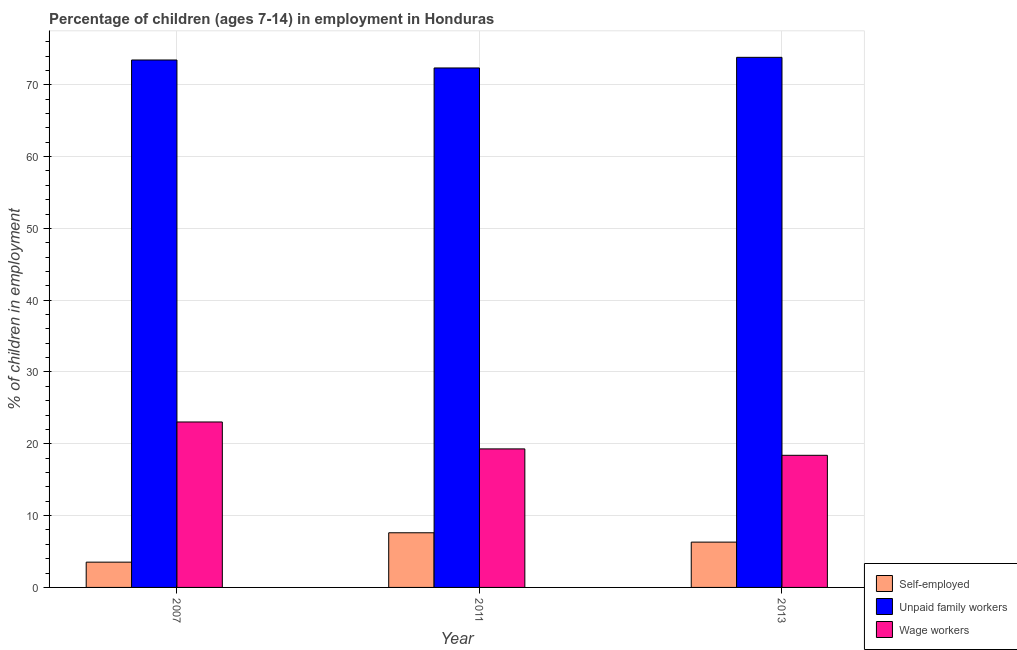How many different coloured bars are there?
Your response must be concise. 3. How many groups of bars are there?
Provide a short and direct response. 3. Are the number of bars on each tick of the X-axis equal?
Give a very brief answer. Yes. How many bars are there on the 2nd tick from the left?
Your response must be concise. 3. How many bars are there on the 1st tick from the right?
Your response must be concise. 3. What is the percentage of children employed as unpaid family workers in 2011?
Ensure brevity in your answer.  72.34. Across all years, what is the maximum percentage of children employed as unpaid family workers?
Your response must be concise. 73.82. Across all years, what is the minimum percentage of children employed as wage workers?
Provide a succinct answer. 18.4. In which year was the percentage of children employed as unpaid family workers minimum?
Offer a very short reply. 2011. What is the total percentage of children employed as unpaid family workers in the graph?
Your answer should be compact. 219.61. What is the difference between the percentage of children employed as wage workers in 2011 and that in 2013?
Make the answer very short. 0.89. What is the difference between the percentage of children employed as wage workers in 2007 and the percentage of self employed children in 2011?
Provide a short and direct response. 3.75. What is the average percentage of children employed as unpaid family workers per year?
Offer a terse response. 73.2. In the year 2007, what is the difference between the percentage of self employed children and percentage of children employed as unpaid family workers?
Provide a short and direct response. 0. What is the ratio of the percentage of children employed as wage workers in 2007 to that in 2013?
Provide a succinct answer. 1.25. Is the difference between the percentage of self employed children in 2007 and 2013 greater than the difference between the percentage of children employed as unpaid family workers in 2007 and 2013?
Your answer should be compact. No. What is the difference between the highest and the second highest percentage of self employed children?
Your answer should be compact. 1.3. What is the difference between the highest and the lowest percentage of children employed as unpaid family workers?
Keep it short and to the point. 1.48. What does the 3rd bar from the left in 2013 represents?
Keep it short and to the point. Wage workers. What does the 3rd bar from the right in 2013 represents?
Your response must be concise. Self-employed. How many bars are there?
Provide a short and direct response. 9. How many years are there in the graph?
Make the answer very short. 3. What is the difference between two consecutive major ticks on the Y-axis?
Ensure brevity in your answer.  10. Are the values on the major ticks of Y-axis written in scientific E-notation?
Your response must be concise. No. Where does the legend appear in the graph?
Give a very brief answer. Bottom right. How many legend labels are there?
Make the answer very short. 3. What is the title of the graph?
Give a very brief answer. Percentage of children (ages 7-14) in employment in Honduras. What is the label or title of the X-axis?
Provide a succinct answer. Year. What is the label or title of the Y-axis?
Ensure brevity in your answer.  % of children in employment. What is the % of children in employment in Self-employed in 2007?
Provide a succinct answer. 3.52. What is the % of children in employment of Unpaid family workers in 2007?
Your answer should be very brief. 73.45. What is the % of children in employment in Wage workers in 2007?
Provide a short and direct response. 23.04. What is the % of children in employment in Self-employed in 2011?
Offer a very short reply. 7.61. What is the % of children in employment in Unpaid family workers in 2011?
Your answer should be compact. 72.34. What is the % of children in employment of Wage workers in 2011?
Keep it short and to the point. 19.29. What is the % of children in employment in Self-employed in 2013?
Offer a very short reply. 6.31. What is the % of children in employment in Unpaid family workers in 2013?
Provide a short and direct response. 73.82. Across all years, what is the maximum % of children in employment of Self-employed?
Give a very brief answer. 7.61. Across all years, what is the maximum % of children in employment in Unpaid family workers?
Offer a very short reply. 73.82. Across all years, what is the maximum % of children in employment in Wage workers?
Your response must be concise. 23.04. Across all years, what is the minimum % of children in employment in Self-employed?
Your answer should be very brief. 3.52. Across all years, what is the minimum % of children in employment in Unpaid family workers?
Keep it short and to the point. 72.34. What is the total % of children in employment of Self-employed in the graph?
Provide a short and direct response. 17.44. What is the total % of children in employment in Unpaid family workers in the graph?
Your answer should be very brief. 219.61. What is the total % of children in employment in Wage workers in the graph?
Your answer should be compact. 60.73. What is the difference between the % of children in employment in Self-employed in 2007 and that in 2011?
Ensure brevity in your answer.  -4.09. What is the difference between the % of children in employment in Unpaid family workers in 2007 and that in 2011?
Offer a terse response. 1.11. What is the difference between the % of children in employment in Wage workers in 2007 and that in 2011?
Offer a very short reply. 3.75. What is the difference between the % of children in employment of Self-employed in 2007 and that in 2013?
Make the answer very short. -2.79. What is the difference between the % of children in employment in Unpaid family workers in 2007 and that in 2013?
Offer a very short reply. -0.37. What is the difference between the % of children in employment of Wage workers in 2007 and that in 2013?
Provide a short and direct response. 4.64. What is the difference between the % of children in employment of Unpaid family workers in 2011 and that in 2013?
Keep it short and to the point. -1.48. What is the difference between the % of children in employment of Wage workers in 2011 and that in 2013?
Provide a succinct answer. 0.89. What is the difference between the % of children in employment of Self-employed in 2007 and the % of children in employment of Unpaid family workers in 2011?
Provide a succinct answer. -68.82. What is the difference between the % of children in employment in Self-employed in 2007 and the % of children in employment in Wage workers in 2011?
Ensure brevity in your answer.  -15.77. What is the difference between the % of children in employment in Unpaid family workers in 2007 and the % of children in employment in Wage workers in 2011?
Offer a very short reply. 54.16. What is the difference between the % of children in employment in Self-employed in 2007 and the % of children in employment in Unpaid family workers in 2013?
Your answer should be compact. -70.3. What is the difference between the % of children in employment of Self-employed in 2007 and the % of children in employment of Wage workers in 2013?
Your answer should be compact. -14.88. What is the difference between the % of children in employment in Unpaid family workers in 2007 and the % of children in employment in Wage workers in 2013?
Make the answer very short. 55.05. What is the difference between the % of children in employment in Self-employed in 2011 and the % of children in employment in Unpaid family workers in 2013?
Give a very brief answer. -66.21. What is the difference between the % of children in employment of Self-employed in 2011 and the % of children in employment of Wage workers in 2013?
Give a very brief answer. -10.79. What is the difference between the % of children in employment in Unpaid family workers in 2011 and the % of children in employment in Wage workers in 2013?
Keep it short and to the point. 53.94. What is the average % of children in employment in Self-employed per year?
Keep it short and to the point. 5.81. What is the average % of children in employment of Unpaid family workers per year?
Offer a very short reply. 73.2. What is the average % of children in employment in Wage workers per year?
Offer a very short reply. 20.24. In the year 2007, what is the difference between the % of children in employment of Self-employed and % of children in employment of Unpaid family workers?
Keep it short and to the point. -69.93. In the year 2007, what is the difference between the % of children in employment in Self-employed and % of children in employment in Wage workers?
Your answer should be very brief. -19.52. In the year 2007, what is the difference between the % of children in employment of Unpaid family workers and % of children in employment of Wage workers?
Your answer should be compact. 50.41. In the year 2011, what is the difference between the % of children in employment of Self-employed and % of children in employment of Unpaid family workers?
Provide a succinct answer. -64.73. In the year 2011, what is the difference between the % of children in employment of Self-employed and % of children in employment of Wage workers?
Ensure brevity in your answer.  -11.68. In the year 2011, what is the difference between the % of children in employment of Unpaid family workers and % of children in employment of Wage workers?
Your answer should be compact. 53.05. In the year 2013, what is the difference between the % of children in employment in Self-employed and % of children in employment in Unpaid family workers?
Your answer should be very brief. -67.51. In the year 2013, what is the difference between the % of children in employment of Self-employed and % of children in employment of Wage workers?
Provide a succinct answer. -12.09. In the year 2013, what is the difference between the % of children in employment in Unpaid family workers and % of children in employment in Wage workers?
Offer a very short reply. 55.42. What is the ratio of the % of children in employment of Self-employed in 2007 to that in 2011?
Your response must be concise. 0.46. What is the ratio of the % of children in employment in Unpaid family workers in 2007 to that in 2011?
Your answer should be very brief. 1.02. What is the ratio of the % of children in employment in Wage workers in 2007 to that in 2011?
Offer a very short reply. 1.19. What is the ratio of the % of children in employment in Self-employed in 2007 to that in 2013?
Offer a very short reply. 0.56. What is the ratio of the % of children in employment in Unpaid family workers in 2007 to that in 2013?
Make the answer very short. 0.99. What is the ratio of the % of children in employment in Wage workers in 2007 to that in 2013?
Give a very brief answer. 1.25. What is the ratio of the % of children in employment in Self-employed in 2011 to that in 2013?
Provide a short and direct response. 1.21. What is the ratio of the % of children in employment of Unpaid family workers in 2011 to that in 2013?
Keep it short and to the point. 0.98. What is the ratio of the % of children in employment of Wage workers in 2011 to that in 2013?
Make the answer very short. 1.05. What is the difference between the highest and the second highest % of children in employment in Unpaid family workers?
Make the answer very short. 0.37. What is the difference between the highest and the second highest % of children in employment in Wage workers?
Give a very brief answer. 3.75. What is the difference between the highest and the lowest % of children in employment in Self-employed?
Keep it short and to the point. 4.09. What is the difference between the highest and the lowest % of children in employment in Unpaid family workers?
Keep it short and to the point. 1.48. What is the difference between the highest and the lowest % of children in employment of Wage workers?
Keep it short and to the point. 4.64. 